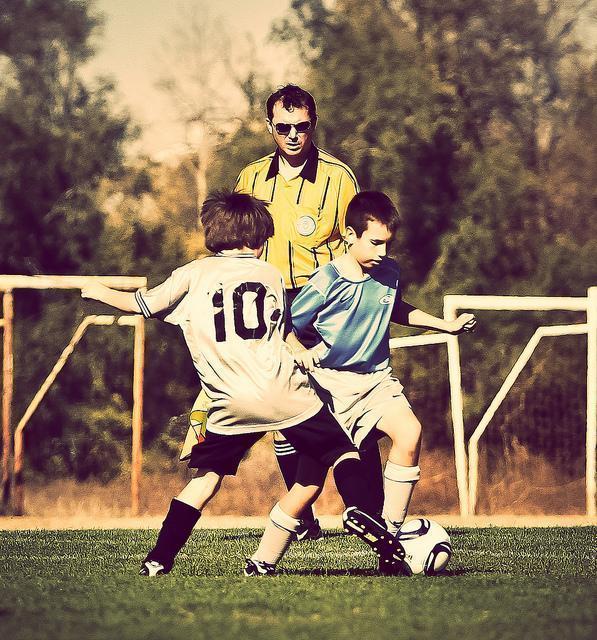What sort of job is the man standing in yellow doing?
Select the accurate response from the four choices given to answer the question.
Options: Secret shopper, game official, cheer leader, field worker. Game official. 